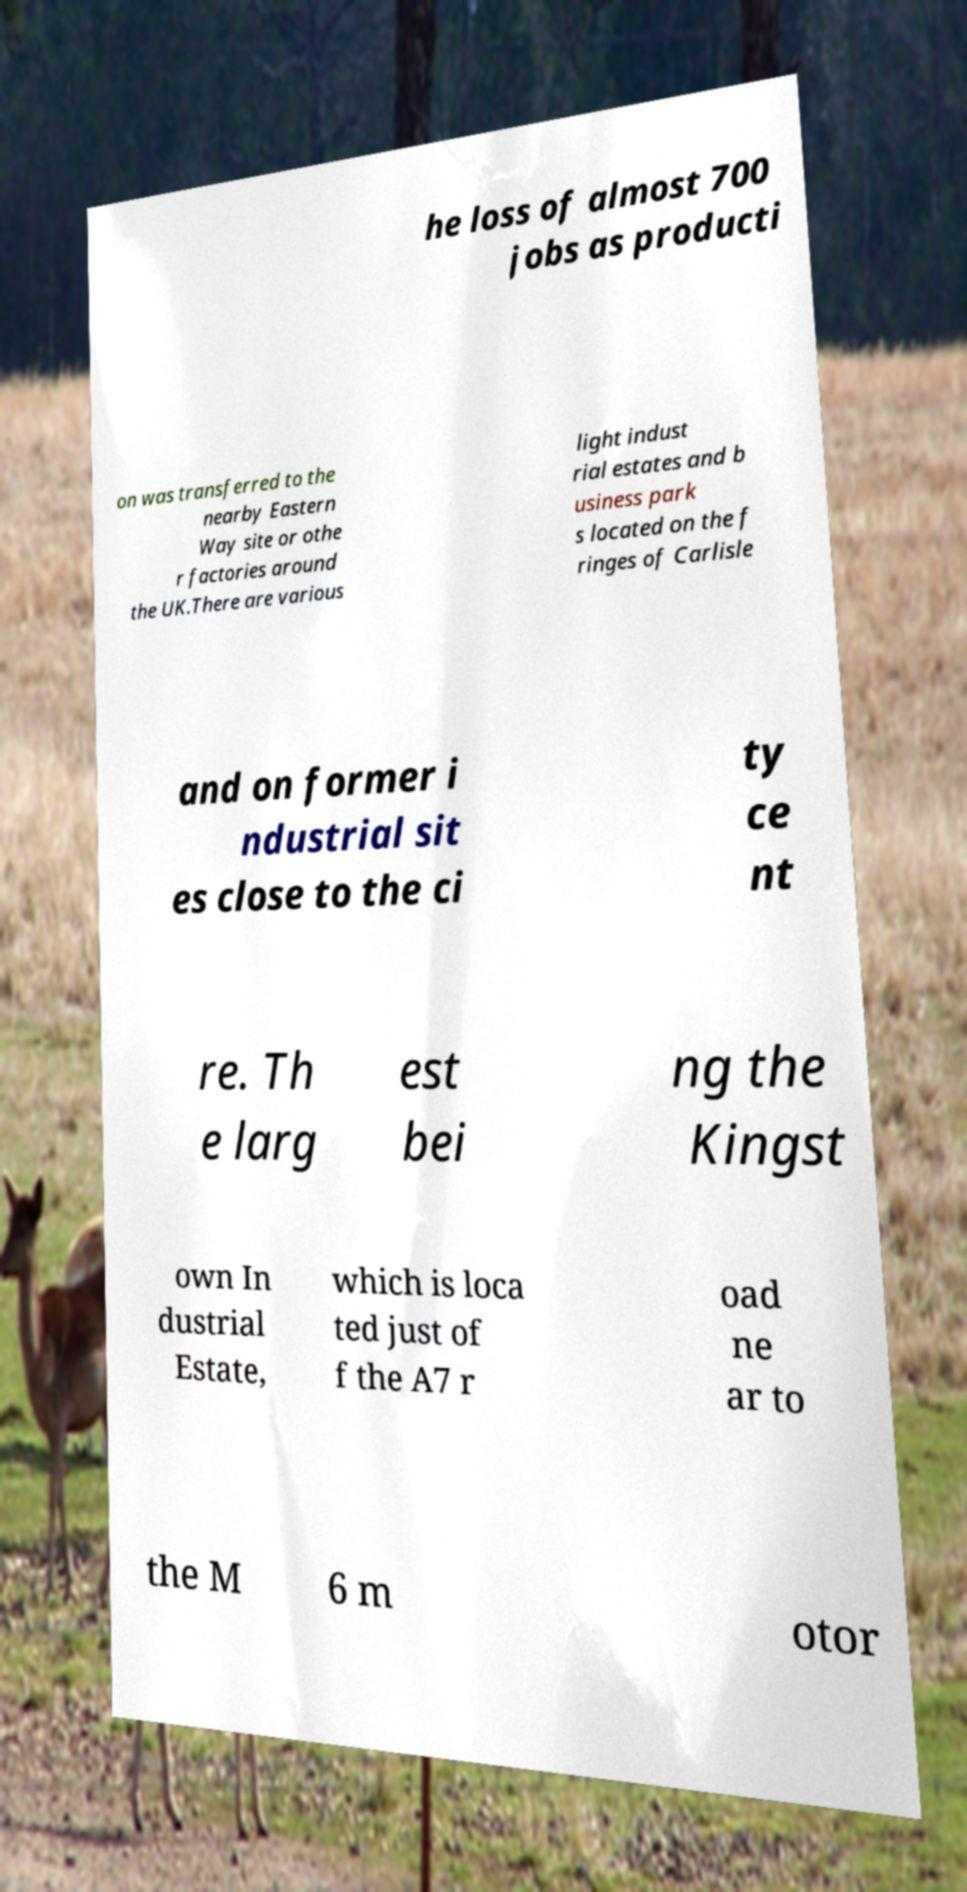Please read and relay the text visible in this image. What does it say? he loss of almost 700 jobs as producti on was transferred to the nearby Eastern Way site or othe r factories around the UK.There are various light indust rial estates and b usiness park s located on the f ringes of Carlisle and on former i ndustrial sit es close to the ci ty ce nt re. Th e larg est bei ng the Kingst own In dustrial Estate, which is loca ted just of f the A7 r oad ne ar to the M 6 m otor 